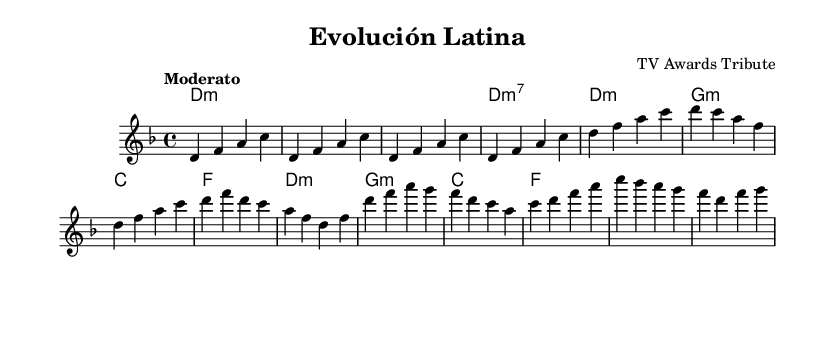What is the key signature of this music? The key signature is D minor, which has one flat (B flat). This can be identified at the beginning of the staff before the first note.
Answer: D minor What is the time signature of this music? The time signature is 4/4, which means there are four beats in a measure and the quarter note gets one beat. This is indicated at the beginning of the piece.
Answer: 4/4 What is the tempo indication in this music? The tempo is marked as Moderato, which indicates a moderate tempo typically around 108-120 beats per minute. This is specified at the start of the score.
Answer: Moderato How many bars are in the intro section? The intro section consists of four bars, which can be counted by noting the measures from the beginning until the first part of the verse starts.
Answer: 4 Which chord is used in the first bar of the Chorus? The first chord in the Chorus is D minor, which can be found by checking the chord symbols below the melody from that section.
Answer: D minor What key center does this piece revolve around? The entire piece revolves around D minor as indicated by both the key signature and the prevalence of D minor chords throughout the score.
Answer: D minor What type of musical form is primarily used in this music? The music primarily follows the verse-chorus form, which consists of distinct sections and repeats, common in popular music styles including Latin genres. This is evident in the structure of the melody and the corresponding harmonies.
Answer: Verse-Chorus 